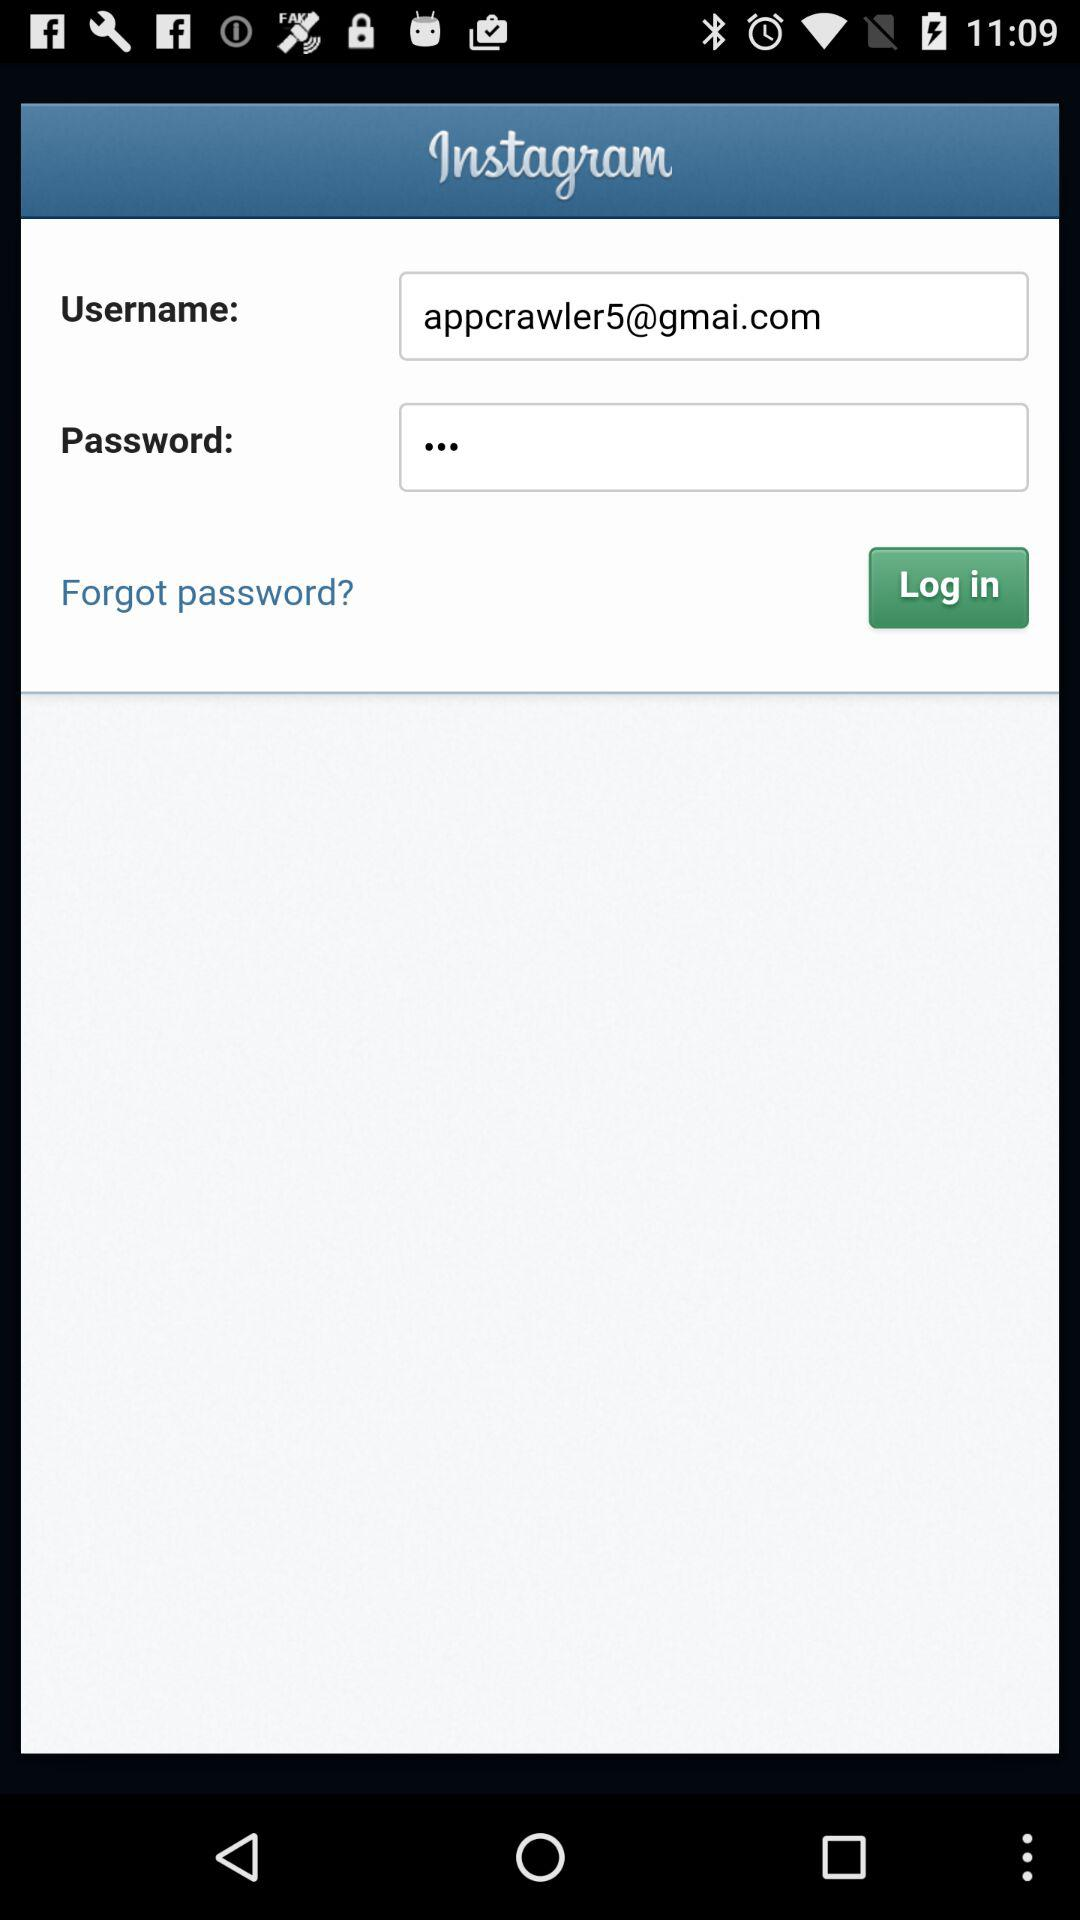What is the email address? The email address is appcrawler5@gmai.com. 